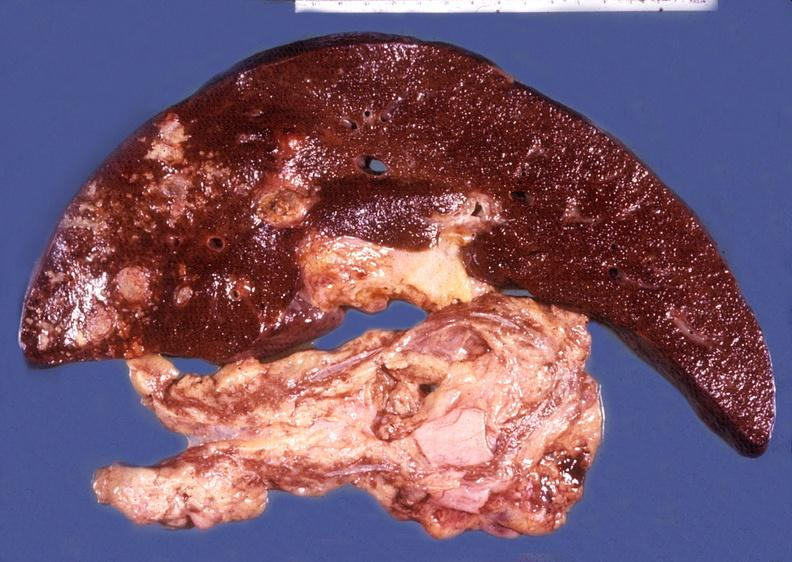what does this image show?
Answer the question using a single word or phrase. Liver and pancreas 